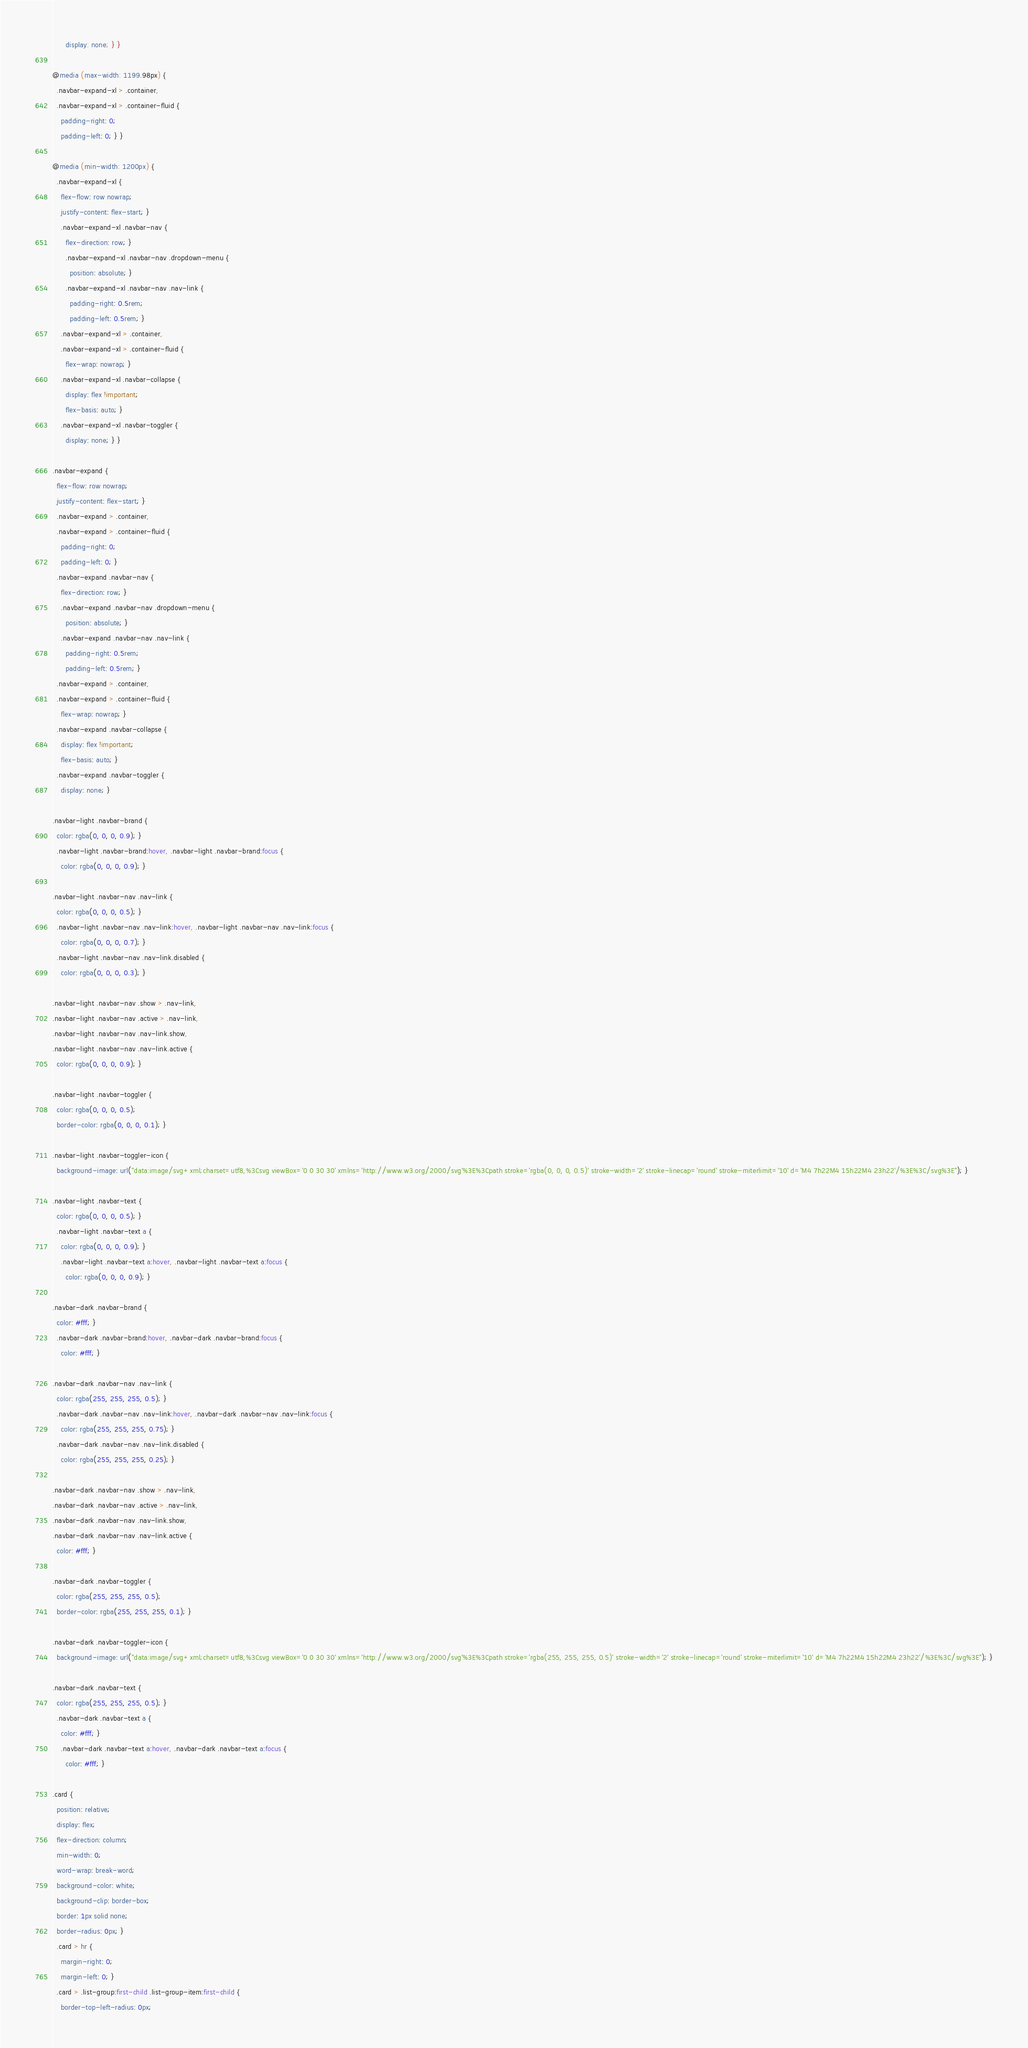Convert code to text. <code><loc_0><loc_0><loc_500><loc_500><_CSS_>      display: none; } }

@media (max-width: 1199.98px) {
  .navbar-expand-xl > .container,
  .navbar-expand-xl > .container-fluid {
    padding-right: 0;
    padding-left: 0; } }

@media (min-width: 1200px) {
  .navbar-expand-xl {
    flex-flow: row nowrap;
    justify-content: flex-start; }
    .navbar-expand-xl .navbar-nav {
      flex-direction: row; }
      .navbar-expand-xl .navbar-nav .dropdown-menu {
        position: absolute; }
      .navbar-expand-xl .navbar-nav .nav-link {
        padding-right: 0.5rem;
        padding-left: 0.5rem; }
    .navbar-expand-xl > .container,
    .navbar-expand-xl > .container-fluid {
      flex-wrap: nowrap; }
    .navbar-expand-xl .navbar-collapse {
      display: flex !important;
      flex-basis: auto; }
    .navbar-expand-xl .navbar-toggler {
      display: none; } }

.navbar-expand {
  flex-flow: row nowrap;
  justify-content: flex-start; }
  .navbar-expand > .container,
  .navbar-expand > .container-fluid {
    padding-right: 0;
    padding-left: 0; }
  .navbar-expand .navbar-nav {
    flex-direction: row; }
    .navbar-expand .navbar-nav .dropdown-menu {
      position: absolute; }
    .navbar-expand .navbar-nav .nav-link {
      padding-right: 0.5rem;
      padding-left: 0.5rem; }
  .navbar-expand > .container,
  .navbar-expand > .container-fluid {
    flex-wrap: nowrap; }
  .navbar-expand .navbar-collapse {
    display: flex !important;
    flex-basis: auto; }
  .navbar-expand .navbar-toggler {
    display: none; }

.navbar-light .navbar-brand {
  color: rgba(0, 0, 0, 0.9); }
  .navbar-light .navbar-brand:hover, .navbar-light .navbar-brand:focus {
    color: rgba(0, 0, 0, 0.9); }

.navbar-light .navbar-nav .nav-link {
  color: rgba(0, 0, 0, 0.5); }
  .navbar-light .navbar-nav .nav-link:hover, .navbar-light .navbar-nav .nav-link:focus {
    color: rgba(0, 0, 0, 0.7); }
  .navbar-light .navbar-nav .nav-link.disabled {
    color: rgba(0, 0, 0, 0.3); }

.navbar-light .navbar-nav .show > .nav-link,
.navbar-light .navbar-nav .active > .nav-link,
.navbar-light .navbar-nav .nav-link.show,
.navbar-light .navbar-nav .nav-link.active {
  color: rgba(0, 0, 0, 0.9); }

.navbar-light .navbar-toggler {
  color: rgba(0, 0, 0, 0.5);
  border-color: rgba(0, 0, 0, 0.1); }

.navbar-light .navbar-toggler-icon {
  background-image: url("data:image/svg+xml;charset=utf8,%3Csvg viewBox='0 0 30 30' xmlns='http://www.w3.org/2000/svg'%3E%3Cpath stroke='rgba(0, 0, 0, 0.5)' stroke-width='2' stroke-linecap='round' stroke-miterlimit='10' d='M4 7h22M4 15h22M4 23h22'/%3E%3C/svg%3E"); }

.navbar-light .navbar-text {
  color: rgba(0, 0, 0, 0.5); }
  .navbar-light .navbar-text a {
    color: rgba(0, 0, 0, 0.9); }
    .navbar-light .navbar-text a:hover, .navbar-light .navbar-text a:focus {
      color: rgba(0, 0, 0, 0.9); }

.navbar-dark .navbar-brand {
  color: #fff; }
  .navbar-dark .navbar-brand:hover, .navbar-dark .navbar-brand:focus {
    color: #fff; }

.navbar-dark .navbar-nav .nav-link {
  color: rgba(255, 255, 255, 0.5); }
  .navbar-dark .navbar-nav .nav-link:hover, .navbar-dark .navbar-nav .nav-link:focus {
    color: rgba(255, 255, 255, 0.75); }
  .navbar-dark .navbar-nav .nav-link.disabled {
    color: rgba(255, 255, 255, 0.25); }

.navbar-dark .navbar-nav .show > .nav-link,
.navbar-dark .navbar-nav .active > .nav-link,
.navbar-dark .navbar-nav .nav-link.show,
.navbar-dark .navbar-nav .nav-link.active {
  color: #fff; }

.navbar-dark .navbar-toggler {
  color: rgba(255, 255, 255, 0.5);
  border-color: rgba(255, 255, 255, 0.1); }

.navbar-dark .navbar-toggler-icon {
  background-image: url("data:image/svg+xml;charset=utf8,%3Csvg viewBox='0 0 30 30' xmlns='http://www.w3.org/2000/svg'%3E%3Cpath stroke='rgba(255, 255, 255, 0.5)' stroke-width='2' stroke-linecap='round' stroke-miterlimit='10' d='M4 7h22M4 15h22M4 23h22'/%3E%3C/svg%3E"); }

.navbar-dark .navbar-text {
  color: rgba(255, 255, 255, 0.5); }
  .navbar-dark .navbar-text a {
    color: #fff; }
    .navbar-dark .navbar-text a:hover, .navbar-dark .navbar-text a:focus {
      color: #fff; }

.card {
  position: relative;
  display: flex;
  flex-direction: column;
  min-width: 0;
  word-wrap: break-word;
  background-color: white;
  background-clip: border-box;
  border: 1px solid none;
  border-radius: 0px; }
  .card > hr {
    margin-right: 0;
    margin-left: 0; }
  .card > .list-group:first-child .list-group-item:first-child {
    border-top-left-radius: 0px;</code> 